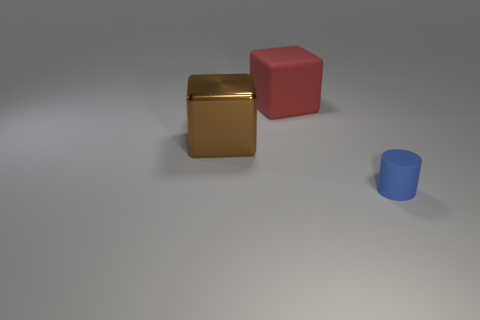Is there a big brown thing of the same shape as the big red thing?
Offer a terse response. Yes. Are there any cylinders that are behind the thing that is right of the matte object behind the tiny blue rubber object?
Provide a succinct answer. No. Is the number of tiny matte cylinders right of the large metal object greater than the number of big red matte cubes in front of the big red block?
Give a very brief answer. Yes. What is the material of the red object that is the same size as the brown block?
Provide a succinct answer. Rubber. How many tiny objects are either red things or shiny blocks?
Give a very brief answer. 0. Do the red matte object and the small blue object have the same shape?
Make the answer very short. No. How many objects are on the left side of the blue matte cylinder and in front of the big red matte cube?
Offer a very short reply. 1. There is a big thing that is made of the same material as the small object; what is its shape?
Offer a very short reply. Cube. Do the metallic cube and the blue rubber cylinder have the same size?
Keep it short and to the point. No. Is the material of the cube behind the brown object the same as the tiny object?
Make the answer very short. Yes. 